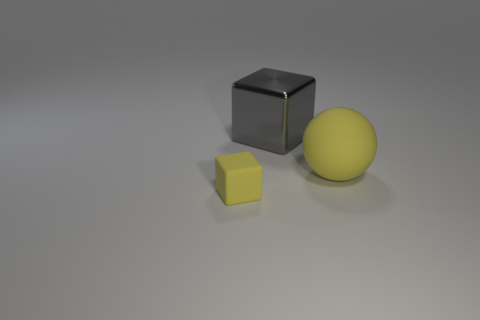Is there anything else that has the same size as the rubber cube?
Offer a very short reply. No. Is there anything else that is made of the same material as the large block?
Your response must be concise. No. Are any yellow cubes visible?
Your answer should be very brief. Yes. Is the cube that is in front of the large yellow thing made of the same material as the sphere?
Offer a very short reply. Yes. Are there any big gray shiny things of the same shape as the small thing?
Give a very brief answer. Yes. Are there an equal number of shiny objects in front of the big sphere and spheres?
Your response must be concise. No. What material is the yellow thing in front of the yellow thing that is right of the gray metallic thing made of?
Your answer should be very brief. Rubber. The small rubber object has what shape?
Offer a very short reply. Cube. Are there an equal number of large yellow rubber balls that are on the left side of the metal cube and big balls that are left of the large yellow rubber thing?
Offer a very short reply. Yes. Does the cube in front of the metal cube have the same color as the rubber thing right of the shiny cube?
Make the answer very short. Yes. 